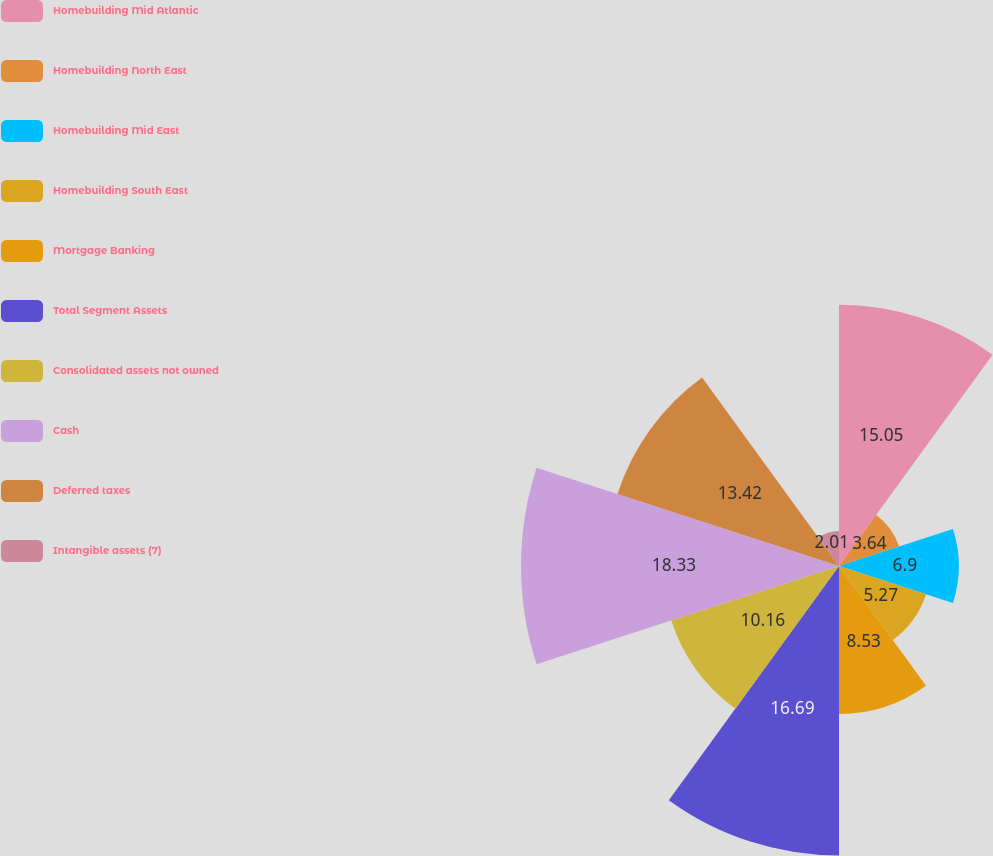<chart> <loc_0><loc_0><loc_500><loc_500><pie_chart><fcel>Homebuilding Mid Atlantic<fcel>Homebuilding North East<fcel>Homebuilding Mid East<fcel>Homebuilding South East<fcel>Mortgage Banking<fcel>Total Segment Assets<fcel>Consolidated assets not owned<fcel>Cash<fcel>Deferred taxes<fcel>Intangible assets (7)<nl><fcel>15.05%<fcel>3.64%<fcel>6.9%<fcel>5.27%<fcel>8.53%<fcel>16.68%<fcel>10.16%<fcel>18.32%<fcel>13.42%<fcel>2.01%<nl></chart> 